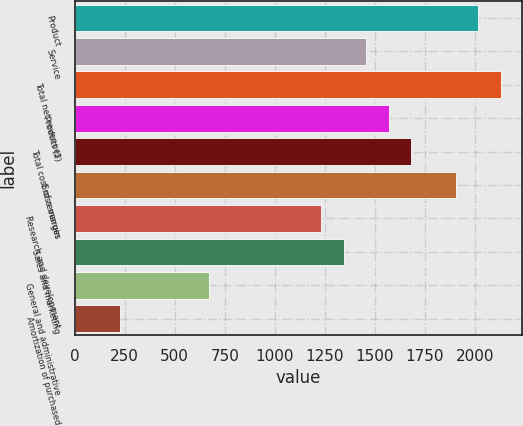Convert chart. <chart><loc_0><loc_0><loc_500><loc_500><bar_chart><fcel>Product<fcel>Service<fcel>Total net revenues<fcel>Product (2)<fcel>Total cost of revenues<fcel>Gross margin<fcel>Research and development<fcel>Sales and marketing<fcel>General and administrative<fcel>Amortization of purchased<nl><fcel>2017.26<fcel>1456.96<fcel>2129.32<fcel>1569.02<fcel>1681.08<fcel>1905.2<fcel>1232.84<fcel>1344.9<fcel>672.54<fcel>224.3<nl></chart> 